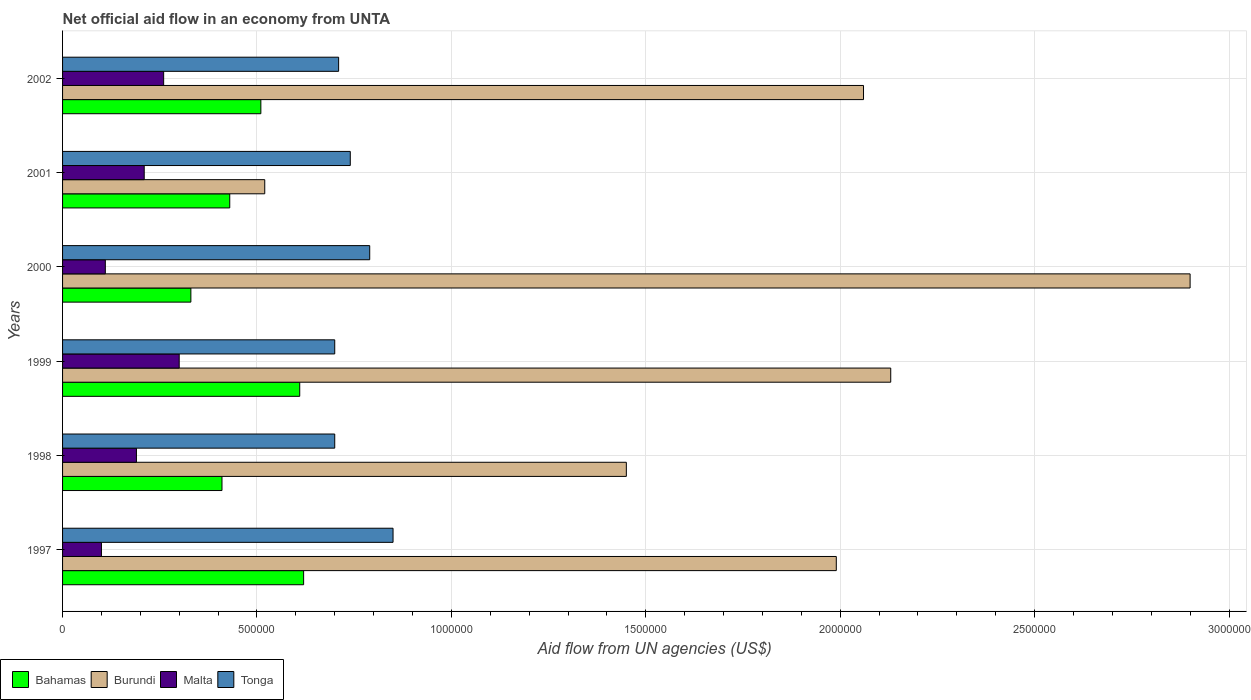How many groups of bars are there?
Provide a short and direct response. 6. Are the number of bars per tick equal to the number of legend labels?
Ensure brevity in your answer.  Yes. How many bars are there on the 2nd tick from the bottom?
Offer a very short reply. 4. In how many cases, is the number of bars for a given year not equal to the number of legend labels?
Provide a short and direct response. 0. What is the net official aid flow in Tonga in 1997?
Give a very brief answer. 8.50e+05. Across all years, what is the maximum net official aid flow in Burundi?
Ensure brevity in your answer.  2.90e+06. Across all years, what is the minimum net official aid flow in Burundi?
Make the answer very short. 5.20e+05. In which year was the net official aid flow in Malta minimum?
Offer a very short reply. 1997. What is the total net official aid flow in Tonga in the graph?
Your response must be concise. 4.49e+06. What is the difference between the net official aid flow in Bahamas in 1998 and the net official aid flow in Burundi in 1997?
Make the answer very short. -1.58e+06. What is the average net official aid flow in Malta per year?
Your answer should be compact. 1.95e+05. What is the ratio of the net official aid flow in Malta in 1997 to that in 2001?
Your answer should be very brief. 0.48. Is the net official aid flow in Malta in 1999 less than that in 2000?
Provide a succinct answer. No. What is the difference between the highest and the second highest net official aid flow in Burundi?
Your answer should be compact. 7.70e+05. What is the difference between the highest and the lowest net official aid flow in Malta?
Your response must be concise. 2.00e+05. Is the sum of the net official aid flow in Tonga in 1997 and 1998 greater than the maximum net official aid flow in Burundi across all years?
Give a very brief answer. No. Is it the case that in every year, the sum of the net official aid flow in Bahamas and net official aid flow in Malta is greater than the sum of net official aid flow in Burundi and net official aid flow in Tonga?
Your response must be concise. No. What does the 2nd bar from the top in 2000 represents?
Provide a succinct answer. Malta. What does the 1st bar from the bottom in 2002 represents?
Your response must be concise. Bahamas. Is it the case that in every year, the sum of the net official aid flow in Malta and net official aid flow in Burundi is greater than the net official aid flow in Tonga?
Keep it short and to the point. No. How many bars are there?
Offer a terse response. 24. Are all the bars in the graph horizontal?
Your answer should be very brief. Yes. How many years are there in the graph?
Your response must be concise. 6. Does the graph contain any zero values?
Offer a very short reply. No. Does the graph contain grids?
Offer a terse response. Yes. How many legend labels are there?
Offer a terse response. 4. What is the title of the graph?
Ensure brevity in your answer.  Net official aid flow in an economy from UNTA. Does "Russian Federation" appear as one of the legend labels in the graph?
Make the answer very short. No. What is the label or title of the X-axis?
Your response must be concise. Aid flow from UN agencies (US$). What is the Aid flow from UN agencies (US$) in Bahamas in 1997?
Your answer should be very brief. 6.20e+05. What is the Aid flow from UN agencies (US$) of Burundi in 1997?
Your response must be concise. 1.99e+06. What is the Aid flow from UN agencies (US$) of Malta in 1997?
Your response must be concise. 1.00e+05. What is the Aid flow from UN agencies (US$) of Tonga in 1997?
Offer a terse response. 8.50e+05. What is the Aid flow from UN agencies (US$) in Burundi in 1998?
Provide a short and direct response. 1.45e+06. What is the Aid flow from UN agencies (US$) in Malta in 1998?
Your answer should be very brief. 1.90e+05. What is the Aid flow from UN agencies (US$) of Bahamas in 1999?
Ensure brevity in your answer.  6.10e+05. What is the Aid flow from UN agencies (US$) of Burundi in 1999?
Ensure brevity in your answer.  2.13e+06. What is the Aid flow from UN agencies (US$) in Malta in 1999?
Provide a short and direct response. 3.00e+05. What is the Aid flow from UN agencies (US$) in Bahamas in 2000?
Give a very brief answer. 3.30e+05. What is the Aid flow from UN agencies (US$) in Burundi in 2000?
Give a very brief answer. 2.90e+06. What is the Aid flow from UN agencies (US$) in Malta in 2000?
Your answer should be very brief. 1.10e+05. What is the Aid flow from UN agencies (US$) of Tonga in 2000?
Make the answer very short. 7.90e+05. What is the Aid flow from UN agencies (US$) of Bahamas in 2001?
Make the answer very short. 4.30e+05. What is the Aid flow from UN agencies (US$) of Burundi in 2001?
Keep it short and to the point. 5.20e+05. What is the Aid flow from UN agencies (US$) of Tonga in 2001?
Provide a succinct answer. 7.40e+05. What is the Aid flow from UN agencies (US$) in Bahamas in 2002?
Provide a succinct answer. 5.10e+05. What is the Aid flow from UN agencies (US$) in Burundi in 2002?
Make the answer very short. 2.06e+06. What is the Aid flow from UN agencies (US$) in Tonga in 2002?
Keep it short and to the point. 7.10e+05. Across all years, what is the maximum Aid flow from UN agencies (US$) of Bahamas?
Offer a terse response. 6.20e+05. Across all years, what is the maximum Aid flow from UN agencies (US$) in Burundi?
Give a very brief answer. 2.90e+06. Across all years, what is the maximum Aid flow from UN agencies (US$) of Tonga?
Give a very brief answer. 8.50e+05. Across all years, what is the minimum Aid flow from UN agencies (US$) of Bahamas?
Give a very brief answer. 3.30e+05. Across all years, what is the minimum Aid flow from UN agencies (US$) of Burundi?
Give a very brief answer. 5.20e+05. Across all years, what is the minimum Aid flow from UN agencies (US$) in Malta?
Ensure brevity in your answer.  1.00e+05. Across all years, what is the minimum Aid flow from UN agencies (US$) in Tonga?
Make the answer very short. 7.00e+05. What is the total Aid flow from UN agencies (US$) in Bahamas in the graph?
Your answer should be very brief. 2.91e+06. What is the total Aid flow from UN agencies (US$) in Burundi in the graph?
Your response must be concise. 1.10e+07. What is the total Aid flow from UN agencies (US$) of Malta in the graph?
Offer a very short reply. 1.17e+06. What is the total Aid flow from UN agencies (US$) in Tonga in the graph?
Offer a very short reply. 4.49e+06. What is the difference between the Aid flow from UN agencies (US$) in Burundi in 1997 and that in 1998?
Ensure brevity in your answer.  5.40e+05. What is the difference between the Aid flow from UN agencies (US$) of Malta in 1997 and that in 1998?
Your answer should be compact. -9.00e+04. What is the difference between the Aid flow from UN agencies (US$) of Bahamas in 1997 and that in 1999?
Ensure brevity in your answer.  10000. What is the difference between the Aid flow from UN agencies (US$) in Burundi in 1997 and that in 1999?
Offer a terse response. -1.40e+05. What is the difference between the Aid flow from UN agencies (US$) of Malta in 1997 and that in 1999?
Your response must be concise. -2.00e+05. What is the difference between the Aid flow from UN agencies (US$) in Burundi in 1997 and that in 2000?
Offer a very short reply. -9.10e+05. What is the difference between the Aid flow from UN agencies (US$) in Malta in 1997 and that in 2000?
Your answer should be compact. -10000. What is the difference between the Aid flow from UN agencies (US$) of Bahamas in 1997 and that in 2001?
Your answer should be very brief. 1.90e+05. What is the difference between the Aid flow from UN agencies (US$) of Burundi in 1997 and that in 2001?
Your answer should be compact. 1.47e+06. What is the difference between the Aid flow from UN agencies (US$) in Malta in 1997 and that in 2001?
Give a very brief answer. -1.10e+05. What is the difference between the Aid flow from UN agencies (US$) of Tonga in 1997 and that in 2001?
Keep it short and to the point. 1.10e+05. What is the difference between the Aid flow from UN agencies (US$) in Tonga in 1997 and that in 2002?
Give a very brief answer. 1.40e+05. What is the difference between the Aid flow from UN agencies (US$) in Bahamas in 1998 and that in 1999?
Your response must be concise. -2.00e+05. What is the difference between the Aid flow from UN agencies (US$) of Burundi in 1998 and that in 1999?
Ensure brevity in your answer.  -6.80e+05. What is the difference between the Aid flow from UN agencies (US$) in Burundi in 1998 and that in 2000?
Make the answer very short. -1.45e+06. What is the difference between the Aid flow from UN agencies (US$) in Malta in 1998 and that in 2000?
Give a very brief answer. 8.00e+04. What is the difference between the Aid flow from UN agencies (US$) in Tonga in 1998 and that in 2000?
Keep it short and to the point. -9.00e+04. What is the difference between the Aid flow from UN agencies (US$) of Burundi in 1998 and that in 2001?
Your answer should be very brief. 9.30e+05. What is the difference between the Aid flow from UN agencies (US$) of Burundi in 1998 and that in 2002?
Your answer should be very brief. -6.10e+05. What is the difference between the Aid flow from UN agencies (US$) of Tonga in 1998 and that in 2002?
Offer a very short reply. -10000. What is the difference between the Aid flow from UN agencies (US$) in Burundi in 1999 and that in 2000?
Offer a terse response. -7.70e+05. What is the difference between the Aid flow from UN agencies (US$) in Bahamas in 1999 and that in 2001?
Your answer should be compact. 1.80e+05. What is the difference between the Aid flow from UN agencies (US$) in Burundi in 1999 and that in 2001?
Your answer should be compact. 1.61e+06. What is the difference between the Aid flow from UN agencies (US$) in Tonga in 1999 and that in 2001?
Keep it short and to the point. -4.00e+04. What is the difference between the Aid flow from UN agencies (US$) in Malta in 1999 and that in 2002?
Your answer should be very brief. 4.00e+04. What is the difference between the Aid flow from UN agencies (US$) of Tonga in 1999 and that in 2002?
Ensure brevity in your answer.  -10000. What is the difference between the Aid flow from UN agencies (US$) of Bahamas in 2000 and that in 2001?
Offer a very short reply. -1.00e+05. What is the difference between the Aid flow from UN agencies (US$) in Burundi in 2000 and that in 2001?
Provide a short and direct response. 2.38e+06. What is the difference between the Aid flow from UN agencies (US$) in Burundi in 2000 and that in 2002?
Offer a terse response. 8.40e+05. What is the difference between the Aid flow from UN agencies (US$) of Malta in 2000 and that in 2002?
Your answer should be compact. -1.50e+05. What is the difference between the Aid flow from UN agencies (US$) of Burundi in 2001 and that in 2002?
Provide a short and direct response. -1.54e+06. What is the difference between the Aid flow from UN agencies (US$) of Tonga in 2001 and that in 2002?
Offer a very short reply. 3.00e+04. What is the difference between the Aid flow from UN agencies (US$) of Bahamas in 1997 and the Aid flow from UN agencies (US$) of Burundi in 1998?
Your answer should be compact. -8.30e+05. What is the difference between the Aid flow from UN agencies (US$) in Bahamas in 1997 and the Aid flow from UN agencies (US$) in Tonga in 1998?
Provide a short and direct response. -8.00e+04. What is the difference between the Aid flow from UN agencies (US$) of Burundi in 1997 and the Aid flow from UN agencies (US$) of Malta in 1998?
Give a very brief answer. 1.80e+06. What is the difference between the Aid flow from UN agencies (US$) of Burundi in 1997 and the Aid flow from UN agencies (US$) of Tonga in 1998?
Offer a very short reply. 1.29e+06. What is the difference between the Aid flow from UN agencies (US$) in Malta in 1997 and the Aid flow from UN agencies (US$) in Tonga in 1998?
Give a very brief answer. -6.00e+05. What is the difference between the Aid flow from UN agencies (US$) in Bahamas in 1997 and the Aid flow from UN agencies (US$) in Burundi in 1999?
Provide a succinct answer. -1.51e+06. What is the difference between the Aid flow from UN agencies (US$) in Bahamas in 1997 and the Aid flow from UN agencies (US$) in Malta in 1999?
Provide a succinct answer. 3.20e+05. What is the difference between the Aid flow from UN agencies (US$) of Bahamas in 1997 and the Aid flow from UN agencies (US$) of Tonga in 1999?
Provide a short and direct response. -8.00e+04. What is the difference between the Aid flow from UN agencies (US$) of Burundi in 1997 and the Aid flow from UN agencies (US$) of Malta in 1999?
Provide a short and direct response. 1.69e+06. What is the difference between the Aid flow from UN agencies (US$) of Burundi in 1997 and the Aid flow from UN agencies (US$) of Tonga in 1999?
Offer a very short reply. 1.29e+06. What is the difference between the Aid flow from UN agencies (US$) in Malta in 1997 and the Aid flow from UN agencies (US$) in Tonga in 1999?
Provide a succinct answer. -6.00e+05. What is the difference between the Aid flow from UN agencies (US$) of Bahamas in 1997 and the Aid flow from UN agencies (US$) of Burundi in 2000?
Give a very brief answer. -2.28e+06. What is the difference between the Aid flow from UN agencies (US$) in Bahamas in 1997 and the Aid flow from UN agencies (US$) in Malta in 2000?
Give a very brief answer. 5.10e+05. What is the difference between the Aid flow from UN agencies (US$) of Burundi in 1997 and the Aid flow from UN agencies (US$) of Malta in 2000?
Your answer should be very brief. 1.88e+06. What is the difference between the Aid flow from UN agencies (US$) in Burundi in 1997 and the Aid flow from UN agencies (US$) in Tonga in 2000?
Make the answer very short. 1.20e+06. What is the difference between the Aid flow from UN agencies (US$) in Malta in 1997 and the Aid flow from UN agencies (US$) in Tonga in 2000?
Offer a very short reply. -6.90e+05. What is the difference between the Aid flow from UN agencies (US$) in Burundi in 1997 and the Aid flow from UN agencies (US$) in Malta in 2001?
Offer a terse response. 1.78e+06. What is the difference between the Aid flow from UN agencies (US$) of Burundi in 1997 and the Aid flow from UN agencies (US$) of Tonga in 2001?
Keep it short and to the point. 1.25e+06. What is the difference between the Aid flow from UN agencies (US$) of Malta in 1997 and the Aid flow from UN agencies (US$) of Tonga in 2001?
Make the answer very short. -6.40e+05. What is the difference between the Aid flow from UN agencies (US$) in Bahamas in 1997 and the Aid flow from UN agencies (US$) in Burundi in 2002?
Ensure brevity in your answer.  -1.44e+06. What is the difference between the Aid flow from UN agencies (US$) of Bahamas in 1997 and the Aid flow from UN agencies (US$) of Malta in 2002?
Your response must be concise. 3.60e+05. What is the difference between the Aid flow from UN agencies (US$) in Burundi in 1997 and the Aid flow from UN agencies (US$) in Malta in 2002?
Offer a terse response. 1.73e+06. What is the difference between the Aid flow from UN agencies (US$) of Burundi in 1997 and the Aid flow from UN agencies (US$) of Tonga in 2002?
Your answer should be compact. 1.28e+06. What is the difference between the Aid flow from UN agencies (US$) of Malta in 1997 and the Aid flow from UN agencies (US$) of Tonga in 2002?
Provide a short and direct response. -6.10e+05. What is the difference between the Aid flow from UN agencies (US$) of Bahamas in 1998 and the Aid flow from UN agencies (US$) of Burundi in 1999?
Make the answer very short. -1.72e+06. What is the difference between the Aid flow from UN agencies (US$) of Bahamas in 1998 and the Aid flow from UN agencies (US$) of Tonga in 1999?
Make the answer very short. -2.90e+05. What is the difference between the Aid flow from UN agencies (US$) in Burundi in 1998 and the Aid flow from UN agencies (US$) in Malta in 1999?
Give a very brief answer. 1.15e+06. What is the difference between the Aid flow from UN agencies (US$) in Burundi in 1998 and the Aid flow from UN agencies (US$) in Tonga in 1999?
Your answer should be compact. 7.50e+05. What is the difference between the Aid flow from UN agencies (US$) of Malta in 1998 and the Aid flow from UN agencies (US$) of Tonga in 1999?
Your answer should be compact. -5.10e+05. What is the difference between the Aid flow from UN agencies (US$) in Bahamas in 1998 and the Aid flow from UN agencies (US$) in Burundi in 2000?
Ensure brevity in your answer.  -2.49e+06. What is the difference between the Aid flow from UN agencies (US$) in Bahamas in 1998 and the Aid flow from UN agencies (US$) in Tonga in 2000?
Ensure brevity in your answer.  -3.80e+05. What is the difference between the Aid flow from UN agencies (US$) in Burundi in 1998 and the Aid flow from UN agencies (US$) in Malta in 2000?
Your answer should be very brief. 1.34e+06. What is the difference between the Aid flow from UN agencies (US$) of Malta in 1998 and the Aid flow from UN agencies (US$) of Tonga in 2000?
Your answer should be compact. -6.00e+05. What is the difference between the Aid flow from UN agencies (US$) of Bahamas in 1998 and the Aid flow from UN agencies (US$) of Tonga in 2001?
Ensure brevity in your answer.  -3.30e+05. What is the difference between the Aid flow from UN agencies (US$) of Burundi in 1998 and the Aid flow from UN agencies (US$) of Malta in 2001?
Your answer should be very brief. 1.24e+06. What is the difference between the Aid flow from UN agencies (US$) of Burundi in 1998 and the Aid flow from UN agencies (US$) of Tonga in 2001?
Offer a very short reply. 7.10e+05. What is the difference between the Aid flow from UN agencies (US$) in Malta in 1998 and the Aid flow from UN agencies (US$) in Tonga in 2001?
Your answer should be compact. -5.50e+05. What is the difference between the Aid flow from UN agencies (US$) in Bahamas in 1998 and the Aid flow from UN agencies (US$) in Burundi in 2002?
Keep it short and to the point. -1.65e+06. What is the difference between the Aid flow from UN agencies (US$) in Bahamas in 1998 and the Aid flow from UN agencies (US$) in Malta in 2002?
Ensure brevity in your answer.  1.50e+05. What is the difference between the Aid flow from UN agencies (US$) of Bahamas in 1998 and the Aid flow from UN agencies (US$) of Tonga in 2002?
Make the answer very short. -3.00e+05. What is the difference between the Aid flow from UN agencies (US$) in Burundi in 1998 and the Aid flow from UN agencies (US$) in Malta in 2002?
Your answer should be very brief. 1.19e+06. What is the difference between the Aid flow from UN agencies (US$) of Burundi in 1998 and the Aid flow from UN agencies (US$) of Tonga in 2002?
Make the answer very short. 7.40e+05. What is the difference between the Aid flow from UN agencies (US$) of Malta in 1998 and the Aid flow from UN agencies (US$) of Tonga in 2002?
Ensure brevity in your answer.  -5.20e+05. What is the difference between the Aid flow from UN agencies (US$) of Bahamas in 1999 and the Aid flow from UN agencies (US$) of Burundi in 2000?
Your response must be concise. -2.29e+06. What is the difference between the Aid flow from UN agencies (US$) of Bahamas in 1999 and the Aid flow from UN agencies (US$) of Malta in 2000?
Your answer should be compact. 5.00e+05. What is the difference between the Aid flow from UN agencies (US$) of Bahamas in 1999 and the Aid flow from UN agencies (US$) of Tonga in 2000?
Provide a succinct answer. -1.80e+05. What is the difference between the Aid flow from UN agencies (US$) in Burundi in 1999 and the Aid flow from UN agencies (US$) in Malta in 2000?
Provide a succinct answer. 2.02e+06. What is the difference between the Aid flow from UN agencies (US$) of Burundi in 1999 and the Aid flow from UN agencies (US$) of Tonga in 2000?
Your response must be concise. 1.34e+06. What is the difference between the Aid flow from UN agencies (US$) in Malta in 1999 and the Aid flow from UN agencies (US$) in Tonga in 2000?
Give a very brief answer. -4.90e+05. What is the difference between the Aid flow from UN agencies (US$) in Bahamas in 1999 and the Aid flow from UN agencies (US$) in Burundi in 2001?
Your answer should be compact. 9.00e+04. What is the difference between the Aid flow from UN agencies (US$) of Bahamas in 1999 and the Aid flow from UN agencies (US$) of Malta in 2001?
Offer a very short reply. 4.00e+05. What is the difference between the Aid flow from UN agencies (US$) in Burundi in 1999 and the Aid flow from UN agencies (US$) in Malta in 2001?
Your response must be concise. 1.92e+06. What is the difference between the Aid flow from UN agencies (US$) in Burundi in 1999 and the Aid flow from UN agencies (US$) in Tonga in 2001?
Give a very brief answer. 1.39e+06. What is the difference between the Aid flow from UN agencies (US$) of Malta in 1999 and the Aid flow from UN agencies (US$) of Tonga in 2001?
Your response must be concise. -4.40e+05. What is the difference between the Aid flow from UN agencies (US$) in Bahamas in 1999 and the Aid flow from UN agencies (US$) in Burundi in 2002?
Offer a terse response. -1.45e+06. What is the difference between the Aid flow from UN agencies (US$) of Bahamas in 1999 and the Aid flow from UN agencies (US$) of Malta in 2002?
Your answer should be compact. 3.50e+05. What is the difference between the Aid flow from UN agencies (US$) in Burundi in 1999 and the Aid flow from UN agencies (US$) in Malta in 2002?
Your answer should be very brief. 1.87e+06. What is the difference between the Aid flow from UN agencies (US$) in Burundi in 1999 and the Aid flow from UN agencies (US$) in Tonga in 2002?
Provide a succinct answer. 1.42e+06. What is the difference between the Aid flow from UN agencies (US$) of Malta in 1999 and the Aid flow from UN agencies (US$) of Tonga in 2002?
Offer a very short reply. -4.10e+05. What is the difference between the Aid flow from UN agencies (US$) of Bahamas in 2000 and the Aid flow from UN agencies (US$) of Malta in 2001?
Keep it short and to the point. 1.20e+05. What is the difference between the Aid flow from UN agencies (US$) in Bahamas in 2000 and the Aid flow from UN agencies (US$) in Tonga in 2001?
Your answer should be very brief. -4.10e+05. What is the difference between the Aid flow from UN agencies (US$) in Burundi in 2000 and the Aid flow from UN agencies (US$) in Malta in 2001?
Provide a short and direct response. 2.69e+06. What is the difference between the Aid flow from UN agencies (US$) of Burundi in 2000 and the Aid flow from UN agencies (US$) of Tonga in 2001?
Provide a short and direct response. 2.16e+06. What is the difference between the Aid flow from UN agencies (US$) of Malta in 2000 and the Aid flow from UN agencies (US$) of Tonga in 2001?
Make the answer very short. -6.30e+05. What is the difference between the Aid flow from UN agencies (US$) of Bahamas in 2000 and the Aid flow from UN agencies (US$) of Burundi in 2002?
Give a very brief answer. -1.73e+06. What is the difference between the Aid flow from UN agencies (US$) in Bahamas in 2000 and the Aid flow from UN agencies (US$) in Tonga in 2002?
Provide a succinct answer. -3.80e+05. What is the difference between the Aid flow from UN agencies (US$) of Burundi in 2000 and the Aid flow from UN agencies (US$) of Malta in 2002?
Make the answer very short. 2.64e+06. What is the difference between the Aid flow from UN agencies (US$) of Burundi in 2000 and the Aid flow from UN agencies (US$) of Tonga in 2002?
Your response must be concise. 2.19e+06. What is the difference between the Aid flow from UN agencies (US$) of Malta in 2000 and the Aid flow from UN agencies (US$) of Tonga in 2002?
Provide a succinct answer. -6.00e+05. What is the difference between the Aid flow from UN agencies (US$) in Bahamas in 2001 and the Aid flow from UN agencies (US$) in Burundi in 2002?
Keep it short and to the point. -1.63e+06. What is the difference between the Aid flow from UN agencies (US$) in Bahamas in 2001 and the Aid flow from UN agencies (US$) in Tonga in 2002?
Provide a short and direct response. -2.80e+05. What is the difference between the Aid flow from UN agencies (US$) of Burundi in 2001 and the Aid flow from UN agencies (US$) of Tonga in 2002?
Give a very brief answer. -1.90e+05. What is the difference between the Aid flow from UN agencies (US$) of Malta in 2001 and the Aid flow from UN agencies (US$) of Tonga in 2002?
Keep it short and to the point. -5.00e+05. What is the average Aid flow from UN agencies (US$) in Bahamas per year?
Make the answer very short. 4.85e+05. What is the average Aid flow from UN agencies (US$) of Burundi per year?
Give a very brief answer. 1.84e+06. What is the average Aid flow from UN agencies (US$) of Malta per year?
Your answer should be compact. 1.95e+05. What is the average Aid flow from UN agencies (US$) of Tonga per year?
Offer a very short reply. 7.48e+05. In the year 1997, what is the difference between the Aid flow from UN agencies (US$) of Bahamas and Aid flow from UN agencies (US$) of Burundi?
Give a very brief answer. -1.37e+06. In the year 1997, what is the difference between the Aid flow from UN agencies (US$) of Bahamas and Aid flow from UN agencies (US$) of Malta?
Offer a terse response. 5.20e+05. In the year 1997, what is the difference between the Aid flow from UN agencies (US$) in Burundi and Aid flow from UN agencies (US$) in Malta?
Give a very brief answer. 1.89e+06. In the year 1997, what is the difference between the Aid flow from UN agencies (US$) of Burundi and Aid flow from UN agencies (US$) of Tonga?
Offer a terse response. 1.14e+06. In the year 1997, what is the difference between the Aid flow from UN agencies (US$) in Malta and Aid flow from UN agencies (US$) in Tonga?
Your response must be concise. -7.50e+05. In the year 1998, what is the difference between the Aid flow from UN agencies (US$) of Bahamas and Aid flow from UN agencies (US$) of Burundi?
Your answer should be very brief. -1.04e+06. In the year 1998, what is the difference between the Aid flow from UN agencies (US$) in Bahamas and Aid flow from UN agencies (US$) in Malta?
Ensure brevity in your answer.  2.20e+05. In the year 1998, what is the difference between the Aid flow from UN agencies (US$) in Burundi and Aid flow from UN agencies (US$) in Malta?
Your answer should be compact. 1.26e+06. In the year 1998, what is the difference between the Aid flow from UN agencies (US$) in Burundi and Aid flow from UN agencies (US$) in Tonga?
Your answer should be very brief. 7.50e+05. In the year 1998, what is the difference between the Aid flow from UN agencies (US$) in Malta and Aid flow from UN agencies (US$) in Tonga?
Provide a short and direct response. -5.10e+05. In the year 1999, what is the difference between the Aid flow from UN agencies (US$) in Bahamas and Aid flow from UN agencies (US$) in Burundi?
Make the answer very short. -1.52e+06. In the year 1999, what is the difference between the Aid flow from UN agencies (US$) of Bahamas and Aid flow from UN agencies (US$) of Tonga?
Provide a succinct answer. -9.00e+04. In the year 1999, what is the difference between the Aid flow from UN agencies (US$) of Burundi and Aid flow from UN agencies (US$) of Malta?
Offer a very short reply. 1.83e+06. In the year 1999, what is the difference between the Aid flow from UN agencies (US$) of Burundi and Aid flow from UN agencies (US$) of Tonga?
Ensure brevity in your answer.  1.43e+06. In the year 1999, what is the difference between the Aid flow from UN agencies (US$) of Malta and Aid flow from UN agencies (US$) of Tonga?
Ensure brevity in your answer.  -4.00e+05. In the year 2000, what is the difference between the Aid flow from UN agencies (US$) of Bahamas and Aid flow from UN agencies (US$) of Burundi?
Your answer should be compact. -2.57e+06. In the year 2000, what is the difference between the Aid flow from UN agencies (US$) of Bahamas and Aid flow from UN agencies (US$) of Malta?
Ensure brevity in your answer.  2.20e+05. In the year 2000, what is the difference between the Aid flow from UN agencies (US$) in Bahamas and Aid flow from UN agencies (US$) in Tonga?
Offer a terse response. -4.60e+05. In the year 2000, what is the difference between the Aid flow from UN agencies (US$) of Burundi and Aid flow from UN agencies (US$) of Malta?
Ensure brevity in your answer.  2.79e+06. In the year 2000, what is the difference between the Aid flow from UN agencies (US$) of Burundi and Aid flow from UN agencies (US$) of Tonga?
Provide a short and direct response. 2.11e+06. In the year 2000, what is the difference between the Aid flow from UN agencies (US$) of Malta and Aid flow from UN agencies (US$) of Tonga?
Your answer should be very brief. -6.80e+05. In the year 2001, what is the difference between the Aid flow from UN agencies (US$) in Bahamas and Aid flow from UN agencies (US$) in Burundi?
Provide a succinct answer. -9.00e+04. In the year 2001, what is the difference between the Aid flow from UN agencies (US$) in Bahamas and Aid flow from UN agencies (US$) in Tonga?
Offer a terse response. -3.10e+05. In the year 2001, what is the difference between the Aid flow from UN agencies (US$) of Burundi and Aid flow from UN agencies (US$) of Malta?
Your response must be concise. 3.10e+05. In the year 2001, what is the difference between the Aid flow from UN agencies (US$) in Malta and Aid flow from UN agencies (US$) in Tonga?
Offer a very short reply. -5.30e+05. In the year 2002, what is the difference between the Aid flow from UN agencies (US$) of Bahamas and Aid flow from UN agencies (US$) of Burundi?
Give a very brief answer. -1.55e+06. In the year 2002, what is the difference between the Aid flow from UN agencies (US$) of Burundi and Aid flow from UN agencies (US$) of Malta?
Give a very brief answer. 1.80e+06. In the year 2002, what is the difference between the Aid flow from UN agencies (US$) in Burundi and Aid flow from UN agencies (US$) in Tonga?
Your answer should be compact. 1.35e+06. In the year 2002, what is the difference between the Aid flow from UN agencies (US$) in Malta and Aid flow from UN agencies (US$) in Tonga?
Your answer should be very brief. -4.50e+05. What is the ratio of the Aid flow from UN agencies (US$) in Bahamas in 1997 to that in 1998?
Ensure brevity in your answer.  1.51. What is the ratio of the Aid flow from UN agencies (US$) in Burundi in 1997 to that in 1998?
Offer a very short reply. 1.37. What is the ratio of the Aid flow from UN agencies (US$) in Malta in 1997 to that in 1998?
Give a very brief answer. 0.53. What is the ratio of the Aid flow from UN agencies (US$) in Tonga in 1997 to that in 1998?
Offer a terse response. 1.21. What is the ratio of the Aid flow from UN agencies (US$) of Bahamas in 1997 to that in 1999?
Provide a short and direct response. 1.02. What is the ratio of the Aid flow from UN agencies (US$) of Burundi in 1997 to that in 1999?
Your answer should be very brief. 0.93. What is the ratio of the Aid flow from UN agencies (US$) in Malta in 1997 to that in 1999?
Offer a very short reply. 0.33. What is the ratio of the Aid flow from UN agencies (US$) of Tonga in 1997 to that in 1999?
Offer a very short reply. 1.21. What is the ratio of the Aid flow from UN agencies (US$) in Bahamas in 1997 to that in 2000?
Provide a short and direct response. 1.88. What is the ratio of the Aid flow from UN agencies (US$) in Burundi in 1997 to that in 2000?
Provide a succinct answer. 0.69. What is the ratio of the Aid flow from UN agencies (US$) of Malta in 1997 to that in 2000?
Your answer should be very brief. 0.91. What is the ratio of the Aid flow from UN agencies (US$) in Tonga in 1997 to that in 2000?
Make the answer very short. 1.08. What is the ratio of the Aid flow from UN agencies (US$) of Bahamas in 1997 to that in 2001?
Make the answer very short. 1.44. What is the ratio of the Aid flow from UN agencies (US$) in Burundi in 1997 to that in 2001?
Offer a terse response. 3.83. What is the ratio of the Aid flow from UN agencies (US$) of Malta in 1997 to that in 2001?
Your answer should be very brief. 0.48. What is the ratio of the Aid flow from UN agencies (US$) in Tonga in 1997 to that in 2001?
Your answer should be very brief. 1.15. What is the ratio of the Aid flow from UN agencies (US$) of Bahamas in 1997 to that in 2002?
Keep it short and to the point. 1.22. What is the ratio of the Aid flow from UN agencies (US$) in Malta in 1997 to that in 2002?
Your answer should be very brief. 0.38. What is the ratio of the Aid flow from UN agencies (US$) in Tonga in 1997 to that in 2002?
Ensure brevity in your answer.  1.2. What is the ratio of the Aid flow from UN agencies (US$) in Bahamas in 1998 to that in 1999?
Provide a short and direct response. 0.67. What is the ratio of the Aid flow from UN agencies (US$) of Burundi in 1998 to that in 1999?
Your answer should be compact. 0.68. What is the ratio of the Aid flow from UN agencies (US$) in Malta in 1998 to that in 1999?
Your response must be concise. 0.63. What is the ratio of the Aid flow from UN agencies (US$) in Bahamas in 1998 to that in 2000?
Make the answer very short. 1.24. What is the ratio of the Aid flow from UN agencies (US$) in Malta in 1998 to that in 2000?
Offer a terse response. 1.73. What is the ratio of the Aid flow from UN agencies (US$) of Tonga in 1998 to that in 2000?
Make the answer very short. 0.89. What is the ratio of the Aid flow from UN agencies (US$) of Bahamas in 1998 to that in 2001?
Give a very brief answer. 0.95. What is the ratio of the Aid flow from UN agencies (US$) in Burundi in 1998 to that in 2001?
Offer a terse response. 2.79. What is the ratio of the Aid flow from UN agencies (US$) of Malta in 1998 to that in 2001?
Provide a short and direct response. 0.9. What is the ratio of the Aid flow from UN agencies (US$) in Tonga in 1998 to that in 2001?
Your answer should be very brief. 0.95. What is the ratio of the Aid flow from UN agencies (US$) in Bahamas in 1998 to that in 2002?
Offer a terse response. 0.8. What is the ratio of the Aid flow from UN agencies (US$) in Burundi in 1998 to that in 2002?
Offer a terse response. 0.7. What is the ratio of the Aid flow from UN agencies (US$) of Malta in 1998 to that in 2002?
Provide a succinct answer. 0.73. What is the ratio of the Aid flow from UN agencies (US$) of Tonga in 1998 to that in 2002?
Ensure brevity in your answer.  0.99. What is the ratio of the Aid flow from UN agencies (US$) of Bahamas in 1999 to that in 2000?
Offer a terse response. 1.85. What is the ratio of the Aid flow from UN agencies (US$) of Burundi in 1999 to that in 2000?
Provide a short and direct response. 0.73. What is the ratio of the Aid flow from UN agencies (US$) in Malta in 1999 to that in 2000?
Your response must be concise. 2.73. What is the ratio of the Aid flow from UN agencies (US$) in Tonga in 1999 to that in 2000?
Give a very brief answer. 0.89. What is the ratio of the Aid flow from UN agencies (US$) of Bahamas in 1999 to that in 2001?
Provide a short and direct response. 1.42. What is the ratio of the Aid flow from UN agencies (US$) of Burundi in 1999 to that in 2001?
Offer a terse response. 4.1. What is the ratio of the Aid flow from UN agencies (US$) of Malta in 1999 to that in 2001?
Offer a very short reply. 1.43. What is the ratio of the Aid flow from UN agencies (US$) of Tonga in 1999 to that in 2001?
Your answer should be compact. 0.95. What is the ratio of the Aid flow from UN agencies (US$) of Bahamas in 1999 to that in 2002?
Provide a short and direct response. 1.2. What is the ratio of the Aid flow from UN agencies (US$) in Burundi in 1999 to that in 2002?
Your answer should be very brief. 1.03. What is the ratio of the Aid flow from UN agencies (US$) in Malta in 1999 to that in 2002?
Your response must be concise. 1.15. What is the ratio of the Aid flow from UN agencies (US$) of Tonga in 1999 to that in 2002?
Give a very brief answer. 0.99. What is the ratio of the Aid flow from UN agencies (US$) of Bahamas in 2000 to that in 2001?
Your answer should be very brief. 0.77. What is the ratio of the Aid flow from UN agencies (US$) of Burundi in 2000 to that in 2001?
Provide a succinct answer. 5.58. What is the ratio of the Aid flow from UN agencies (US$) in Malta in 2000 to that in 2001?
Your response must be concise. 0.52. What is the ratio of the Aid flow from UN agencies (US$) in Tonga in 2000 to that in 2001?
Your answer should be very brief. 1.07. What is the ratio of the Aid flow from UN agencies (US$) of Bahamas in 2000 to that in 2002?
Provide a succinct answer. 0.65. What is the ratio of the Aid flow from UN agencies (US$) of Burundi in 2000 to that in 2002?
Make the answer very short. 1.41. What is the ratio of the Aid flow from UN agencies (US$) of Malta in 2000 to that in 2002?
Offer a terse response. 0.42. What is the ratio of the Aid flow from UN agencies (US$) of Tonga in 2000 to that in 2002?
Provide a succinct answer. 1.11. What is the ratio of the Aid flow from UN agencies (US$) of Bahamas in 2001 to that in 2002?
Keep it short and to the point. 0.84. What is the ratio of the Aid flow from UN agencies (US$) in Burundi in 2001 to that in 2002?
Provide a short and direct response. 0.25. What is the ratio of the Aid flow from UN agencies (US$) in Malta in 2001 to that in 2002?
Your answer should be compact. 0.81. What is the ratio of the Aid flow from UN agencies (US$) of Tonga in 2001 to that in 2002?
Offer a terse response. 1.04. What is the difference between the highest and the second highest Aid flow from UN agencies (US$) of Burundi?
Provide a short and direct response. 7.70e+05. What is the difference between the highest and the second highest Aid flow from UN agencies (US$) of Tonga?
Offer a terse response. 6.00e+04. What is the difference between the highest and the lowest Aid flow from UN agencies (US$) in Burundi?
Your response must be concise. 2.38e+06. What is the difference between the highest and the lowest Aid flow from UN agencies (US$) in Malta?
Your answer should be very brief. 2.00e+05. 